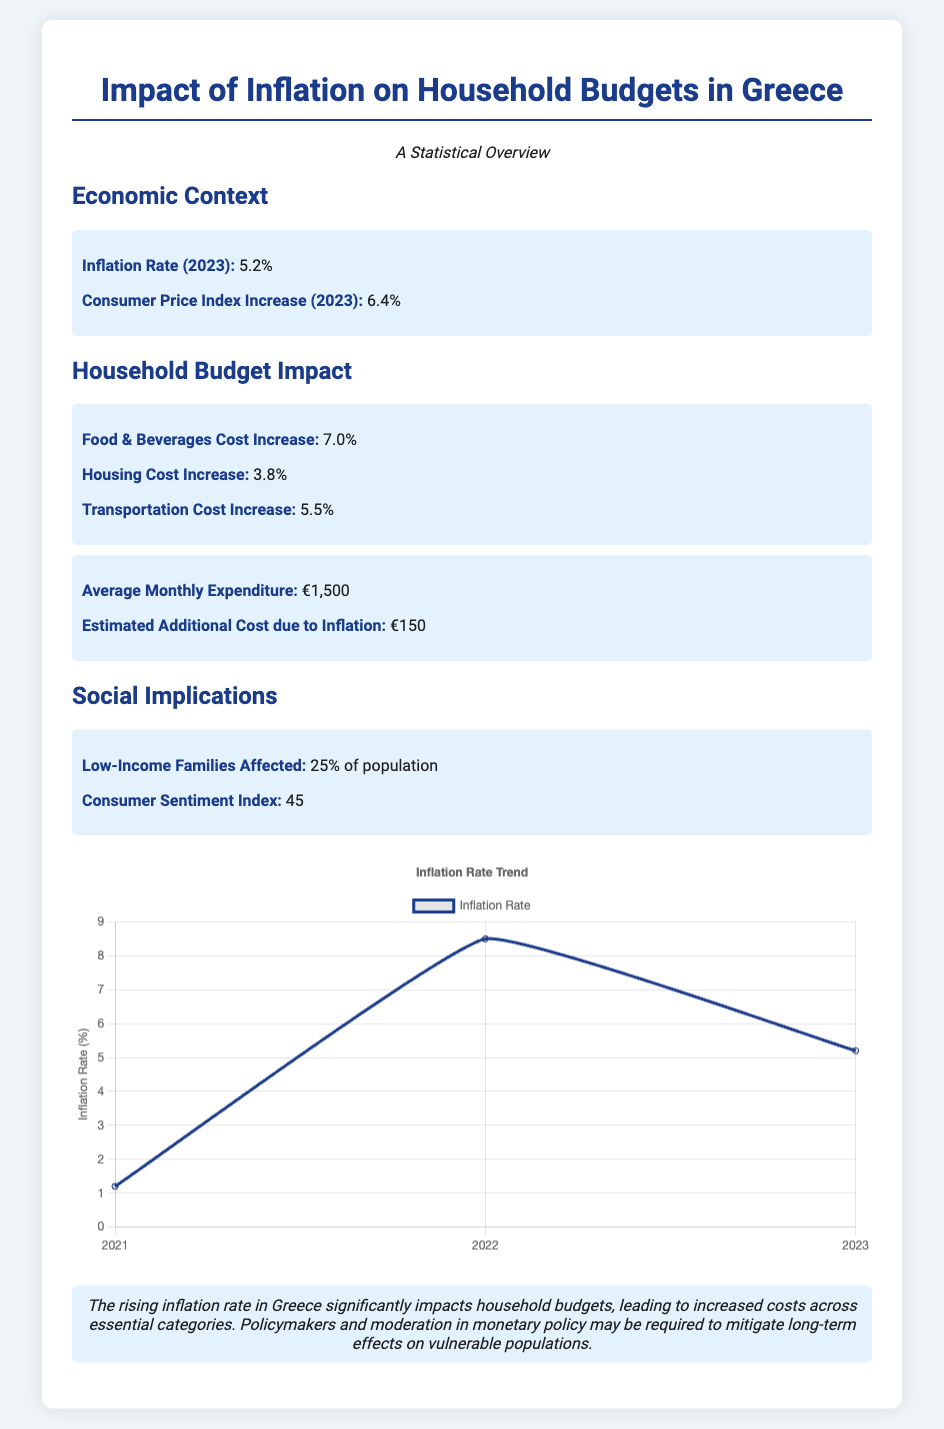what is the inflation rate in 2023? The inflation rate for 2023 is explicitly stated in the document, highlighting its significance.
Answer: 5.2% what is the average monthly expenditure for households? The document provides a specific figure for the average monthly expenditure of households.
Answer: €1,500 what percentage of low-income families are affected by inflation? The document directly mentions the percentage of the population affected by inflation, crucial for understanding its social impact.
Answer: 25% what was the increase in food and beverages cost? The specific increase in the cost of food and beverages is noted, which impacts household budgets significantly.
Answer: 7.0% how much additional cost is estimated due to inflation? The document states an estimated additional cost attributed to inflation, relevant for budgeting purposes.
Answer: €150 what was the consumer price index increase in 2023? The increase in the consumer price index is mentioned as a key statistical figure for the year.
Answer: 6.4% what is the consumer sentiment index? The sentiment index reflects consumer attitudes and is explicitly provided in the document for analysis.
Answer: 45 what was the inflation rate trend from 2021 to 2023? The trend of inflation rates over the years is summarized and significant for understanding economic changes.
Answer: 1.2%, 8.5%, 5.2% 